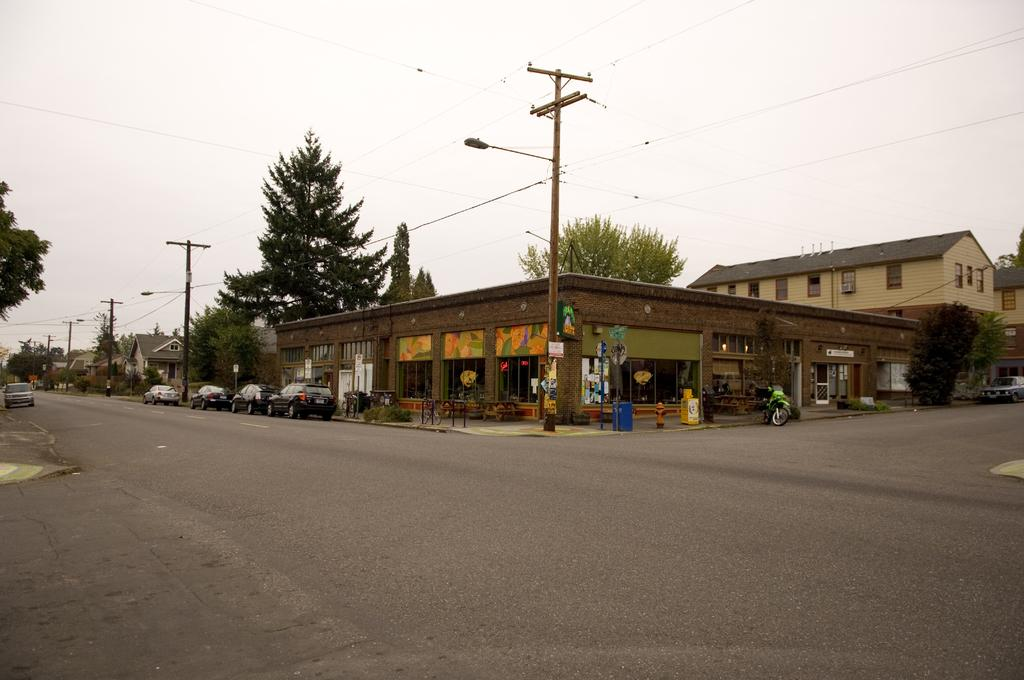What is at the bottom of the image? There is a road at the bottom of the image. What can be seen on the road? There are vehicles on the road. What is visible in the background of the image? Buildings, poles, electric wires, trees, hoardings, a dustbin, and other objects are visible in the background of the image. What part of the natural environment is visible in the image? Trees are visible in the background of the image. What is visible in the sky in the image? The sky is visible in the background of the image. How many pizzas are being served on top of the buildings in the image? There are no pizzas visible in the image. What type of stew is being cooked in the dustbin in the image? There is no stew present in the image; it is a dustbin. 